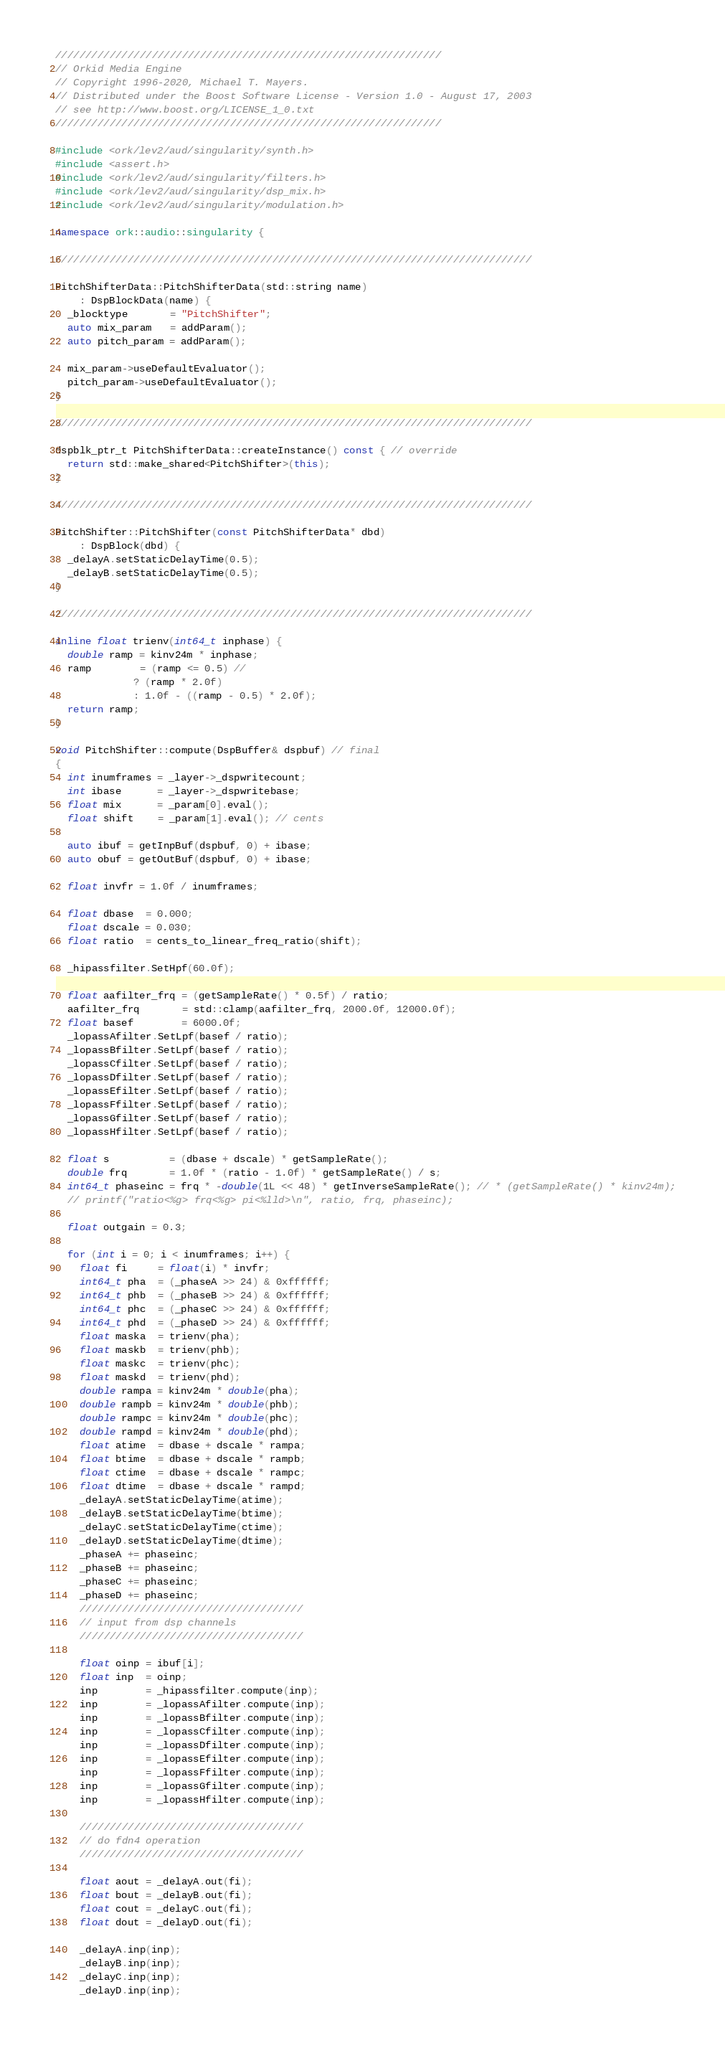<code> <loc_0><loc_0><loc_500><loc_500><_C++_>////////////////////////////////////////////////////////////////
// Orkid Media Engine
// Copyright 1996-2020, Michael T. Mayers.
// Distributed under the Boost Software License - Version 1.0 - August 17, 2003
// see http://www.boost.org/LICENSE_1_0.txt
////////////////////////////////////////////////////////////////

#include <ork/lev2/aud/singularity/synth.h>
#include <assert.h>
#include <ork/lev2/aud/singularity/filters.h>
#include <ork/lev2/aud/singularity/dsp_mix.h>
#include <ork/lev2/aud/singularity/modulation.h>

namespace ork::audio::singularity {

///////////////////////////////////////////////////////////////////////////////

PitchShifterData::PitchShifterData(std::string name)
    : DspBlockData(name) {
  _blocktype       = "PitchShifter";
  auto mix_param   = addParam();
  auto pitch_param = addParam();

  mix_param->useDefaultEvaluator();
  pitch_param->useDefaultEvaluator();
}

///////////////////////////////////////////////////////////////////////////////

dspblk_ptr_t PitchShifterData::createInstance() const { // override
  return std::make_shared<PitchShifter>(this);
}

///////////////////////////////////////////////////////////////////////////////

PitchShifter::PitchShifter(const PitchShifterData* dbd)
    : DspBlock(dbd) {
  _delayA.setStaticDelayTime(0.5);
  _delayB.setStaticDelayTime(0.5);
}

///////////////////////////////////////////////////////////////////////////////

inline float trienv(int64_t inphase) {
  double ramp = kinv24m * inphase;
  ramp        = (ramp <= 0.5) //
             ? (ramp * 2.0f)
             : 1.0f - ((ramp - 0.5) * 2.0f);
  return ramp;
}

void PitchShifter::compute(DspBuffer& dspbuf) // final
{
  int inumframes = _layer->_dspwritecount;
  int ibase      = _layer->_dspwritebase;
  float mix      = _param[0].eval();
  float shift    = _param[1].eval(); // cents

  auto ibuf = getInpBuf(dspbuf, 0) + ibase;
  auto obuf = getOutBuf(dspbuf, 0) + ibase;

  float invfr = 1.0f / inumframes;

  float dbase  = 0.000;
  float dscale = 0.030;
  float ratio  = cents_to_linear_freq_ratio(shift);

  _hipassfilter.SetHpf(60.0f);

  float aafilter_frq = (getSampleRate() * 0.5f) / ratio;
  aafilter_frq       = std::clamp(aafilter_frq, 2000.0f, 12000.0f);
  float basef        = 6000.0f;
  _lopassAfilter.SetLpf(basef / ratio);
  _lopassBfilter.SetLpf(basef / ratio);
  _lopassCfilter.SetLpf(basef / ratio);
  _lopassDfilter.SetLpf(basef / ratio);
  _lopassEfilter.SetLpf(basef / ratio);
  _lopassFfilter.SetLpf(basef / ratio);
  _lopassGfilter.SetLpf(basef / ratio);
  _lopassHfilter.SetLpf(basef / ratio);

  float s          = (dbase + dscale) * getSampleRate();
  double frq       = 1.0f * (ratio - 1.0f) * getSampleRate() / s;
  int64_t phaseinc = frq * -double(1L << 48) * getInverseSampleRate(); // * (getSampleRate() * kinv24m);
  // printf("ratio<%g> frq<%g> pi<%lld>\n", ratio, frq, phaseinc);

  float outgain = 0.3;

  for (int i = 0; i < inumframes; i++) {
    float fi     = float(i) * invfr;
    int64_t pha  = (_phaseA >> 24) & 0xffffff;
    int64_t phb  = (_phaseB >> 24) & 0xffffff;
    int64_t phc  = (_phaseC >> 24) & 0xffffff;
    int64_t phd  = (_phaseD >> 24) & 0xffffff;
    float maska  = trienv(pha);
    float maskb  = trienv(phb);
    float maskc  = trienv(phc);
    float maskd  = trienv(phd);
    double rampa = kinv24m * double(pha);
    double rampb = kinv24m * double(phb);
    double rampc = kinv24m * double(phc);
    double rampd = kinv24m * double(phd);
    float atime  = dbase + dscale * rampa;
    float btime  = dbase + dscale * rampb;
    float ctime  = dbase + dscale * rampc;
    float dtime  = dbase + dscale * rampd;
    _delayA.setStaticDelayTime(atime);
    _delayB.setStaticDelayTime(btime);
    _delayC.setStaticDelayTime(ctime);
    _delayD.setStaticDelayTime(dtime);
    _phaseA += phaseinc;
    _phaseB += phaseinc;
    _phaseC += phaseinc;
    _phaseD += phaseinc;
    /////////////////////////////////////
    // input from dsp channels
    /////////////////////////////////////

    float oinp = ibuf[i];
    float inp  = oinp;
    inp        = _hipassfilter.compute(inp);
    inp        = _lopassAfilter.compute(inp);
    inp        = _lopassBfilter.compute(inp);
    inp        = _lopassCfilter.compute(inp);
    inp        = _lopassDfilter.compute(inp);
    inp        = _lopassEfilter.compute(inp);
    inp        = _lopassFfilter.compute(inp);
    inp        = _lopassGfilter.compute(inp);
    inp        = _lopassHfilter.compute(inp);

    /////////////////////////////////////
    // do fdn4 operation
    /////////////////////////////////////

    float aout = _delayA.out(fi);
    float bout = _delayB.out(fi);
    float cout = _delayC.out(fi);
    float dout = _delayD.out(fi);

    _delayA.inp(inp);
    _delayB.inp(inp);
    _delayC.inp(inp);
    _delayD.inp(inp);
</code> 